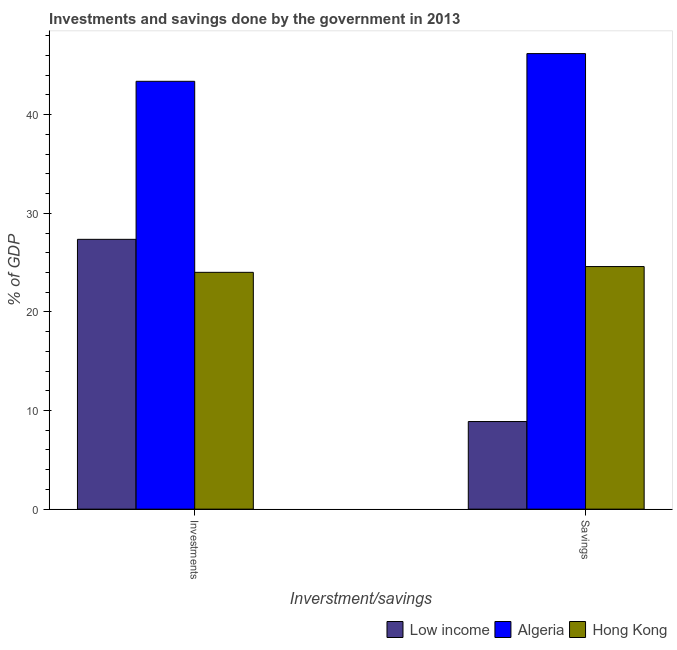How many different coloured bars are there?
Your answer should be very brief. 3. How many groups of bars are there?
Make the answer very short. 2. Are the number of bars per tick equal to the number of legend labels?
Offer a very short reply. Yes. Are the number of bars on each tick of the X-axis equal?
Keep it short and to the point. Yes. What is the label of the 2nd group of bars from the left?
Make the answer very short. Savings. What is the investments of government in Algeria?
Your response must be concise. 43.38. Across all countries, what is the maximum investments of government?
Your response must be concise. 43.38. Across all countries, what is the minimum savings of government?
Your answer should be compact. 8.88. In which country was the savings of government maximum?
Your answer should be compact. Algeria. In which country was the savings of government minimum?
Ensure brevity in your answer.  Low income. What is the total investments of government in the graph?
Make the answer very short. 94.76. What is the difference between the savings of government in Hong Kong and that in Algeria?
Offer a very short reply. -21.59. What is the difference between the savings of government in Hong Kong and the investments of government in Algeria?
Your answer should be very brief. -18.78. What is the average investments of government per country?
Keep it short and to the point. 31.59. What is the difference between the savings of government and investments of government in Hong Kong?
Provide a short and direct response. 0.59. In how many countries, is the investments of government greater than 40 %?
Your answer should be compact. 1. What is the ratio of the savings of government in Hong Kong to that in Algeria?
Give a very brief answer. 0.53. In how many countries, is the savings of government greater than the average savings of government taken over all countries?
Offer a very short reply. 1. What does the 3rd bar from the left in Investments represents?
Provide a short and direct response. Hong Kong. What does the 2nd bar from the right in Investments represents?
Your response must be concise. Algeria. Are all the bars in the graph horizontal?
Give a very brief answer. No. What is the difference between two consecutive major ticks on the Y-axis?
Your response must be concise. 10. Does the graph contain any zero values?
Offer a very short reply. No. Does the graph contain grids?
Your answer should be compact. No. How many legend labels are there?
Provide a short and direct response. 3. What is the title of the graph?
Your answer should be compact. Investments and savings done by the government in 2013. Does "Israel" appear as one of the legend labels in the graph?
Provide a succinct answer. No. What is the label or title of the X-axis?
Offer a terse response. Inverstment/savings. What is the label or title of the Y-axis?
Provide a succinct answer. % of GDP. What is the % of GDP of Low income in Investments?
Your answer should be very brief. 27.36. What is the % of GDP in Algeria in Investments?
Offer a terse response. 43.38. What is the % of GDP of Hong Kong in Investments?
Your response must be concise. 24.01. What is the % of GDP in Low income in Savings?
Give a very brief answer. 8.88. What is the % of GDP of Algeria in Savings?
Your answer should be very brief. 46.19. What is the % of GDP of Hong Kong in Savings?
Ensure brevity in your answer.  24.6. Across all Inverstment/savings, what is the maximum % of GDP in Low income?
Keep it short and to the point. 27.36. Across all Inverstment/savings, what is the maximum % of GDP of Algeria?
Your answer should be compact. 46.19. Across all Inverstment/savings, what is the maximum % of GDP in Hong Kong?
Provide a short and direct response. 24.6. Across all Inverstment/savings, what is the minimum % of GDP of Low income?
Your answer should be compact. 8.88. Across all Inverstment/savings, what is the minimum % of GDP in Algeria?
Make the answer very short. 43.38. Across all Inverstment/savings, what is the minimum % of GDP of Hong Kong?
Ensure brevity in your answer.  24.01. What is the total % of GDP of Low income in the graph?
Your answer should be compact. 36.24. What is the total % of GDP in Algeria in the graph?
Your response must be concise. 89.58. What is the total % of GDP in Hong Kong in the graph?
Give a very brief answer. 48.61. What is the difference between the % of GDP in Low income in Investments and that in Savings?
Offer a terse response. 18.48. What is the difference between the % of GDP in Algeria in Investments and that in Savings?
Make the answer very short. -2.81. What is the difference between the % of GDP of Hong Kong in Investments and that in Savings?
Your answer should be very brief. -0.59. What is the difference between the % of GDP of Low income in Investments and the % of GDP of Algeria in Savings?
Your response must be concise. -18.83. What is the difference between the % of GDP of Low income in Investments and the % of GDP of Hong Kong in Savings?
Your response must be concise. 2.76. What is the difference between the % of GDP in Algeria in Investments and the % of GDP in Hong Kong in Savings?
Ensure brevity in your answer.  18.78. What is the average % of GDP in Low income per Inverstment/savings?
Keep it short and to the point. 18.12. What is the average % of GDP in Algeria per Inverstment/savings?
Give a very brief answer. 44.79. What is the average % of GDP of Hong Kong per Inverstment/savings?
Provide a succinct answer. 24.31. What is the difference between the % of GDP of Low income and % of GDP of Algeria in Investments?
Make the answer very short. -16.02. What is the difference between the % of GDP in Low income and % of GDP in Hong Kong in Investments?
Provide a short and direct response. 3.35. What is the difference between the % of GDP in Algeria and % of GDP in Hong Kong in Investments?
Your answer should be very brief. 19.37. What is the difference between the % of GDP of Low income and % of GDP of Algeria in Savings?
Offer a terse response. -37.31. What is the difference between the % of GDP of Low income and % of GDP of Hong Kong in Savings?
Your answer should be very brief. -15.72. What is the difference between the % of GDP in Algeria and % of GDP in Hong Kong in Savings?
Provide a short and direct response. 21.59. What is the ratio of the % of GDP of Low income in Investments to that in Savings?
Your response must be concise. 3.08. What is the ratio of the % of GDP in Algeria in Investments to that in Savings?
Your answer should be compact. 0.94. What is the ratio of the % of GDP in Hong Kong in Investments to that in Savings?
Keep it short and to the point. 0.98. What is the difference between the highest and the second highest % of GDP of Low income?
Provide a short and direct response. 18.48. What is the difference between the highest and the second highest % of GDP of Algeria?
Give a very brief answer. 2.81. What is the difference between the highest and the second highest % of GDP in Hong Kong?
Offer a very short reply. 0.59. What is the difference between the highest and the lowest % of GDP in Low income?
Provide a succinct answer. 18.48. What is the difference between the highest and the lowest % of GDP of Algeria?
Your answer should be very brief. 2.81. What is the difference between the highest and the lowest % of GDP in Hong Kong?
Your answer should be compact. 0.59. 